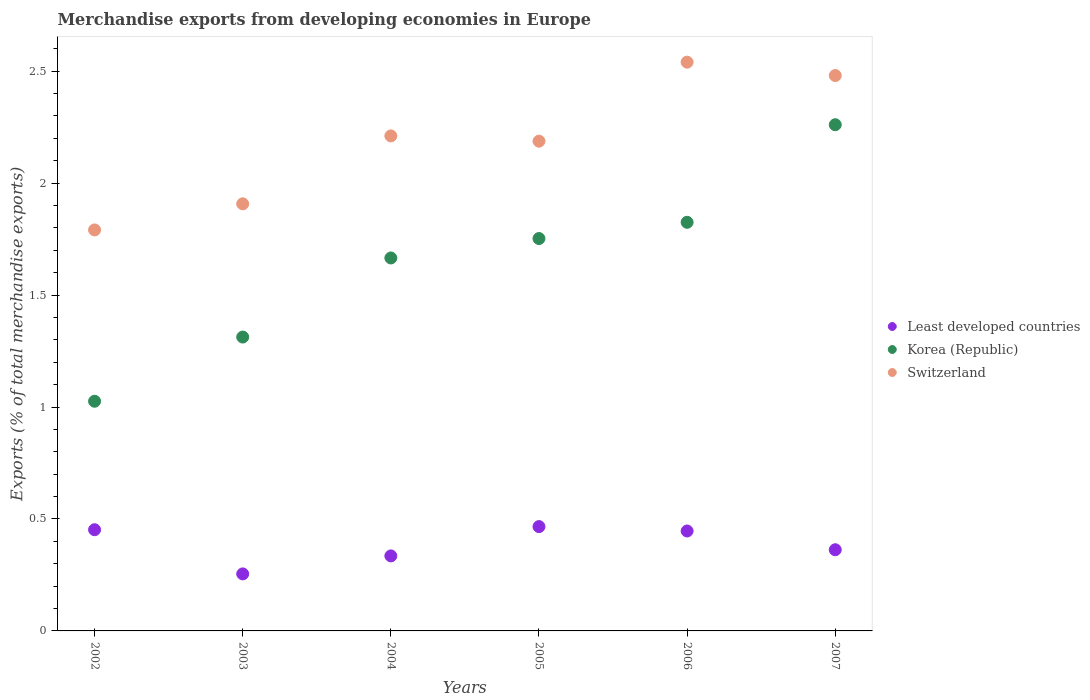How many different coloured dotlines are there?
Ensure brevity in your answer.  3. Is the number of dotlines equal to the number of legend labels?
Offer a terse response. Yes. What is the percentage of total merchandise exports in Switzerland in 2003?
Give a very brief answer. 1.91. Across all years, what is the maximum percentage of total merchandise exports in Least developed countries?
Make the answer very short. 0.47. Across all years, what is the minimum percentage of total merchandise exports in Switzerland?
Your answer should be compact. 1.79. In which year was the percentage of total merchandise exports in Least developed countries maximum?
Provide a short and direct response. 2005. What is the total percentage of total merchandise exports in Korea (Republic) in the graph?
Provide a succinct answer. 9.84. What is the difference between the percentage of total merchandise exports in Korea (Republic) in 2003 and that in 2005?
Give a very brief answer. -0.44. What is the difference between the percentage of total merchandise exports in Least developed countries in 2004 and the percentage of total merchandise exports in Korea (Republic) in 2002?
Provide a short and direct response. -0.69. What is the average percentage of total merchandise exports in Switzerland per year?
Give a very brief answer. 2.19. In the year 2002, what is the difference between the percentage of total merchandise exports in Switzerland and percentage of total merchandise exports in Korea (Republic)?
Your answer should be very brief. 0.77. In how many years, is the percentage of total merchandise exports in Least developed countries greater than 0.5 %?
Your answer should be compact. 0. What is the ratio of the percentage of total merchandise exports in Least developed countries in 2002 to that in 2003?
Keep it short and to the point. 1.77. Is the percentage of total merchandise exports in Switzerland in 2006 less than that in 2007?
Ensure brevity in your answer.  No. Is the difference between the percentage of total merchandise exports in Switzerland in 2003 and 2006 greater than the difference between the percentage of total merchandise exports in Korea (Republic) in 2003 and 2006?
Keep it short and to the point. No. What is the difference between the highest and the second highest percentage of total merchandise exports in Switzerland?
Give a very brief answer. 0.06. What is the difference between the highest and the lowest percentage of total merchandise exports in Switzerland?
Your response must be concise. 0.75. Is the sum of the percentage of total merchandise exports in Switzerland in 2004 and 2007 greater than the maximum percentage of total merchandise exports in Korea (Republic) across all years?
Offer a terse response. Yes. Does the percentage of total merchandise exports in Least developed countries monotonically increase over the years?
Ensure brevity in your answer.  No. Is the percentage of total merchandise exports in Switzerland strictly greater than the percentage of total merchandise exports in Korea (Republic) over the years?
Make the answer very short. Yes. How many years are there in the graph?
Provide a succinct answer. 6. Are the values on the major ticks of Y-axis written in scientific E-notation?
Make the answer very short. No. Does the graph contain any zero values?
Offer a very short reply. No. Does the graph contain grids?
Provide a succinct answer. No. What is the title of the graph?
Offer a terse response. Merchandise exports from developing economies in Europe. What is the label or title of the Y-axis?
Offer a terse response. Exports (% of total merchandise exports). What is the Exports (% of total merchandise exports) in Least developed countries in 2002?
Give a very brief answer. 0.45. What is the Exports (% of total merchandise exports) in Korea (Republic) in 2002?
Your answer should be very brief. 1.03. What is the Exports (% of total merchandise exports) of Switzerland in 2002?
Your answer should be compact. 1.79. What is the Exports (% of total merchandise exports) of Least developed countries in 2003?
Offer a terse response. 0.25. What is the Exports (% of total merchandise exports) of Korea (Republic) in 2003?
Provide a short and direct response. 1.31. What is the Exports (% of total merchandise exports) in Switzerland in 2003?
Make the answer very short. 1.91. What is the Exports (% of total merchandise exports) in Least developed countries in 2004?
Give a very brief answer. 0.34. What is the Exports (% of total merchandise exports) of Korea (Republic) in 2004?
Your response must be concise. 1.67. What is the Exports (% of total merchandise exports) in Switzerland in 2004?
Offer a very short reply. 2.21. What is the Exports (% of total merchandise exports) in Least developed countries in 2005?
Offer a very short reply. 0.47. What is the Exports (% of total merchandise exports) in Korea (Republic) in 2005?
Ensure brevity in your answer.  1.75. What is the Exports (% of total merchandise exports) in Switzerland in 2005?
Your answer should be very brief. 2.19. What is the Exports (% of total merchandise exports) of Least developed countries in 2006?
Your answer should be very brief. 0.45. What is the Exports (% of total merchandise exports) in Korea (Republic) in 2006?
Your response must be concise. 1.82. What is the Exports (% of total merchandise exports) in Switzerland in 2006?
Your response must be concise. 2.54. What is the Exports (% of total merchandise exports) in Least developed countries in 2007?
Give a very brief answer. 0.36. What is the Exports (% of total merchandise exports) of Korea (Republic) in 2007?
Keep it short and to the point. 2.26. What is the Exports (% of total merchandise exports) of Switzerland in 2007?
Provide a succinct answer. 2.48. Across all years, what is the maximum Exports (% of total merchandise exports) of Least developed countries?
Provide a short and direct response. 0.47. Across all years, what is the maximum Exports (% of total merchandise exports) in Korea (Republic)?
Make the answer very short. 2.26. Across all years, what is the maximum Exports (% of total merchandise exports) in Switzerland?
Offer a terse response. 2.54. Across all years, what is the minimum Exports (% of total merchandise exports) of Least developed countries?
Provide a short and direct response. 0.25. Across all years, what is the minimum Exports (% of total merchandise exports) in Korea (Republic)?
Give a very brief answer. 1.03. Across all years, what is the minimum Exports (% of total merchandise exports) in Switzerland?
Keep it short and to the point. 1.79. What is the total Exports (% of total merchandise exports) of Least developed countries in the graph?
Provide a succinct answer. 2.32. What is the total Exports (% of total merchandise exports) in Korea (Republic) in the graph?
Your answer should be compact. 9.84. What is the total Exports (% of total merchandise exports) of Switzerland in the graph?
Provide a succinct answer. 13.12. What is the difference between the Exports (% of total merchandise exports) of Least developed countries in 2002 and that in 2003?
Your answer should be very brief. 0.2. What is the difference between the Exports (% of total merchandise exports) in Korea (Republic) in 2002 and that in 2003?
Your response must be concise. -0.29. What is the difference between the Exports (% of total merchandise exports) in Switzerland in 2002 and that in 2003?
Ensure brevity in your answer.  -0.12. What is the difference between the Exports (% of total merchandise exports) of Least developed countries in 2002 and that in 2004?
Keep it short and to the point. 0.12. What is the difference between the Exports (% of total merchandise exports) of Korea (Republic) in 2002 and that in 2004?
Provide a succinct answer. -0.64. What is the difference between the Exports (% of total merchandise exports) in Switzerland in 2002 and that in 2004?
Keep it short and to the point. -0.42. What is the difference between the Exports (% of total merchandise exports) of Least developed countries in 2002 and that in 2005?
Ensure brevity in your answer.  -0.01. What is the difference between the Exports (% of total merchandise exports) of Korea (Republic) in 2002 and that in 2005?
Your response must be concise. -0.73. What is the difference between the Exports (% of total merchandise exports) in Switzerland in 2002 and that in 2005?
Provide a succinct answer. -0.4. What is the difference between the Exports (% of total merchandise exports) of Least developed countries in 2002 and that in 2006?
Provide a succinct answer. 0.01. What is the difference between the Exports (% of total merchandise exports) in Korea (Republic) in 2002 and that in 2006?
Your response must be concise. -0.8. What is the difference between the Exports (% of total merchandise exports) in Switzerland in 2002 and that in 2006?
Make the answer very short. -0.75. What is the difference between the Exports (% of total merchandise exports) in Least developed countries in 2002 and that in 2007?
Keep it short and to the point. 0.09. What is the difference between the Exports (% of total merchandise exports) of Korea (Republic) in 2002 and that in 2007?
Your answer should be very brief. -1.24. What is the difference between the Exports (% of total merchandise exports) in Switzerland in 2002 and that in 2007?
Provide a succinct answer. -0.69. What is the difference between the Exports (% of total merchandise exports) of Least developed countries in 2003 and that in 2004?
Provide a succinct answer. -0.08. What is the difference between the Exports (% of total merchandise exports) of Korea (Republic) in 2003 and that in 2004?
Keep it short and to the point. -0.35. What is the difference between the Exports (% of total merchandise exports) of Switzerland in 2003 and that in 2004?
Ensure brevity in your answer.  -0.3. What is the difference between the Exports (% of total merchandise exports) of Least developed countries in 2003 and that in 2005?
Keep it short and to the point. -0.21. What is the difference between the Exports (% of total merchandise exports) in Korea (Republic) in 2003 and that in 2005?
Your answer should be compact. -0.44. What is the difference between the Exports (% of total merchandise exports) of Switzerland in 2003 and that in 2005?
Your answer should be compact. -0.28. What is the difference between the Exports (% of total merchandise exports) in Least developed countries in 2003 and that in 2006?
Keep it short and to the point. -0.19. What is the difference between the Exports (% of total merchandise exports) of Korea (Republic) in 2003 and that in 2006?
Provide a short and direct response. -0.51. What is the difference between the Exports (% of total merchandise exports) in Switzerland in 2003 and that in 2006?
Ensure brevity in your answer.  -0.63. What is the difference between the Exports (% of total merchandise exports) of Least developed countries in 2003 and that in 2007?
Offer a terse response. -0.11. What is the difference between the Exports (% of total merchandise exports) in Korea (Republic) in 2003 and that in 2007?
Your response must be concise. -0.95. What is the difference between the Exports (% of total merchandise exports) of Switzerland in 2003 and that in 2007?
Ensure brevity in your answer.  -0.57. What is the difference between the Exports (% of total merchandise exports) in Least developed countries in 2004 and that in 2005?
Provide a short and direct response. -0.13. What is the difference between the Exports (% of total merchandise exports) of Korea (Republic) in 2004 and that in 2005?
Your answer should be compact. -0.09. What is the difference between the Exports (% of total merchandise exports) in Switzerland in 2004 and that in 2005?
Make the answer very short. 0.02. What is the difference between the Exports (% of total merchandise exports) of Least developed countries in 2004 and that in 2006?
Provide a short and direct response. -0.11. What is the difference between the Exports (% of total merchandise exports) in Korea (Republic) in 2004 and that in 2006?
Ensure brevity in your answer.  -0.16. What is the difference between the Exports (% of total merchandise exports) of Switzerland in 2004 and that in 2006?
Offer a very short reply. -0.33. What is the difference between the Exports (% of total merchandise exports) in Least developed countries in 2004 and that in 2007?
Offer a terse response. -0.03. What is the difference between the Exports (% of total merchandise exports) in Korea (Republic) in 2004 and that in 2007?
Your answer should be very brief. -0.6. What is the difference between the Exports (% of total merchandise exports) in Switzerland in 2004 and that in 2007?
Your answer should be compact. -0.27. What is the difference between the Exports (% of total merchandise exports) of Least developed countries in 2005 and that in 2006?
Keep it short and to the point. 0.02. What is the difference between the Exports (% of total merchandise exports) in Korea (Republic) in 2005 and that in 2006?
Offer a very short reply. -0.07. What is the difference between the Exports (% of total merchandise exports) of Switzerland in 2005 and that in 2006?
Offer a terse response. -0.35. What is the difference between the Exports (% of total merchandise exports) of Least developed countries in 2005 and that in 2007?
Give a very brief answer. 0.1. What is the difference between the Exports (% of total merchandise exports) in Korea (Republic) in 2005 and that in 2007?
Make the answer very short. -0.51. What is the difference between the Exports (% of total merchandise exports) in Switzerland in 2005 and that in 2007?
Make the answer very short. -0.29. What is the difference between the Exports (% of total merchandise exports) in Least developed countries in 2006 and that in 2007?
Ensure brevity in your answer.  0.08. What is the difference between the Exports (% of total merchandise exports) of Korea (Republic) in 2006 and that in 2007?
Provide a succinct answer. -0.44. What is the difference between the Exports (% of total merchandise exports) of Switzerland in 2006 and that in 2007?
Your response must be concise. 0.06. What is the difference between the Exports (% of total merchandise exports) of Least developed countries in 2002 and the Exports (% of total merchandise exports) of Korea (Republic) in 2003?
Provide a succinct answer. -0.86. What is the difference between the Exports (% of total merchandise exports) in Least developed countries in 2002 and the Exports (% of total merchandise exports) in Switzerland in 2003?
Provide a short and direct response. -1.46. What is the difference between the Exports (% of total merchandise exports) of Korea (Republic) in 2002 and the Exports (% of total merchandise exports) of Switzerland in 2003?
Make the answer very short. -0.88. What is the difference between the Exports (% of total merchandise exports) of Least developed countries in 2002 and the Exports (% of total merchandise exports) of Korea (Republic) in 2004?
Your answer should be very brief. -1.21. What is the difference between the Exports (% of total merchandise exports) of Least developed countries in 2002 and the Exports (% of total merchandise exports) of Switzerland in 2004?
Your response must be concise. -1.76. What is the difference between the Exports (% of total merchandise exports) in Korea (Republic) in 2002 and the Exports (% of total merchandise exports) in Switzerland in 2004?
Your response must be concise. -1.19. What is the difference between the Exports (% of total merchandise exports) in Least developed countries in 2002 and the Exports (% of total merchandise exports) in Korea (Republic) in 2005?
Your response must be concise. -1.3. What is the difference between the Exports (% of total merchandise exports) in Least developed countries in 2002 and the Exports (% of total merchandise exports) in Switzerland in 2005?
Give a very brief answer. -1.74. What is the difference between the Exports (% of total merchandise exports) in Korea (Republic) in 2002 and the Exports (% of total merchandise exports) in Switzerland in 2005?
Ensure brevity in your answer.  -1.16. What is the difference between the Exports (% of total merchandise exports) in Least developed countries in 2002 and the Exports (% of total merchandise exports) in Korea (Republic) in 2006?
Offer a terse response. -1.37. What is the difference between the Exports (% of total merchandise exports) in Least developed countries in 2002 and the Exports (% of total merchandise exports) in Switzerland in 2006?
Provide a short and direct response. -2.09. What is the difference between the Exports (% of total merchandise exports) of Korea (Republic) in 2002 and the Exports (% of total merchandise exports) of Switzerland in 2006?
Your answer should be very brief. -1.51. What is the difference between the Exports (% of total merchandise exports) of Least developed countries in 2002 and the Exports (% of total merchandise exports) of Korea (Republic) in 2007?
Keep it short and to the point. -1.81. What is the difference between the Exports (% of total merchandise exports) of Least developed countries in 2002 and the Exports (% of total merchandise exports) of Switzerland in 2007?
Offer a terse response. -2.03. What is the difference between the Exports (% of total merchandise exports) in Korea (Republic) in 2002 and the Exports (% of total merchandise exports) in Switzerland in 2007?
Ensure brevity in your answer.  -1.45. What is the difference between the Exports (% of total merchandise exports) of Least developed countries in 2003 and the Exports (% of total merchandise exports) of Korea (Republic) in 2004?
Your response must be concise. -1.41. What is the difference between the Exports (% of total merchandise exports) of Least developed countries in 2003 and the Exports (% of total merchandise exports) of Switzerland in 2004?
Your response must be concise. -1.96. What is the difference between the Exports (% of total merchandise exports) in Korea (Republic) in 2003 and the Exports (% of total merchandise exports) in Switzerland in 2004?
Keep it short and to the point. -0.9. What is the difference between the Exports (% of total merchandise exports) of Least developed countries in 2003 and the Exports (% of total merchandise exports) of Korea (Republic) in 2005?
Your answer should be very brief. -1.5. What is the difference between the Exports (% of total merchandise exports) of Least developed countries in 2003 and the Exports (% of total merchandise exports) of Switzerland in 2005?
Provide a short and direct response. -1.93. What is the difference between the Exports (% of total merchandise exports) in Korea (Republic) in 2003 and the Exports (% of total merchandise exports) in Switzerland in 2005?
Your answer should be compact. -0.87. What is the difference between the Exports (% of total merchandise exports) in Least developed countries in 2003 and the Exports (% of total merchandise exports) in Korea (Republic) in 2006?
Your response must be concise. -1.57. What is the difference between the Exports (% of total merchandise exports) in Least developed countries in 2003 and the Exports (% of total merchandise exports) in Switzerland in 2006?
Provide a succinct answer. -2.29. What is the difference between the Exports (% of total merchandise exports) in Korea (Republic) in 2003 and the Exports (% of total merchandise exports) in Switzerland in 2006?
Provide a short and direct response. -1.23. What is the difference between the Exports (% of total merchandise exports) of Least developed countries in 2003 and the Exports (% of total merchandise exports) of Korea (Republic) in 2007?
Offer a terse response. -2.01. What is the difference between the Exports (% of total merchandise exports) in Least developed countries in 2003 and the Exports (% of total merchandise exports) in Switzerland in 2007?
Your answer should be compact. -2.23. What is the difference between the Exports (% of total merchandise exports) in Korea (Republic) in 2003 and the Exports (% of total merchandise exports) in Switzerland in 2007?
Offer a terse response. -1.17. What is the difference between the Exports (% of total merchandise exports) in Least developed countries in 2004 and the Exports (% of total merchandise exports) in Korea (Republic) in 2005?
Offer a very short reply. -1.42. What is the difference between the Exports (% of total merchandise exports) of Least developed countries in 2004 and the Exports (% of total merchandise exports) of Switzerland in 2005?
Offer a very short reply. -1.85. What is the difference between the Exports (% of total merchandise exports) of Korea (Republic) in 2004 and the Exports (% of total merchandise exports) of Switzerland in 2005?
Provide a short and direct response. -0.52. What is the difference between the Exports (% of total merchandise exports) in Least developed countries in 2004 and the Exports (% of total merchandise exports) in Korea (Republic) in 2006?
Keep it short and to the point. -1.49. What is the difference between the Exports (% of total merchandise exports) in Least developed countries in 2004 and the Exports (% of total merchandise exports) in Switzerland in 2006?
Your answer should be compact. -2.21. What is the difference between the Exports (% of total merchandise exports) of Korea (Republic) in 2004 and the Exports (% of total merchandise exports) of Switzerland in 2006?
Your response must be concise. -0.87. What is the difference between the Exports (% of total merchandise exports) of Least developed countries in 2004 and the Exports (% of total merchandise exports) of Korea (Republic) in 2007?
Keep it short and to the point. -1.93. What is the difference between the Exports (% of total merchandise exports) in Least developed countries in 2004 and the Exports (% of total merchandise exports) in Switzerland in 2007?
Offer a terse response. -2.15. What is the difference between the Exports (% of total merchandise exports) of Korea (Republic) in 2004 and the Exports (% of total merchandise exports) of Switzerland in 2007?
Give a very brief answer. -0.81. What is the difference between the Exports (% of total merchandise exports) in Least developed countries in 2005 and the Exports (% of total merchandise exports) in Korea (Republic) in 2006?
Provide a short and direct response. -1.36. What is the difference between the Exports (% of total merchandise exports) of Least developed countries in 2005 and the Exports (% of total merchandise exports) of Switzerland in 2006?
Ensure brevity in your answer.  -2.07. What is the difference between the Exports (% of total merchandise exports) of Korea (Republic) in 2005 and the Exports (% of total merchandise exports) of Switzerland in 2006?
Provide a succinct answer. -0.79. What is the difference between the Exports (% of total merchandise exports) in Least developed countries in 2005 and the Exports (% of total merchandise exports) in Korea (Republic) in 2007?
Provide a short and direct response. -1.79. What is the difference between the Exports (% of total merchandise exports) in Least developed countries in 2005 and the Exports (% of total merchandise exports) in Switzerland in 2007?
Your response must be concise. -2.01. What is the difference between the Exports (% of total merchandise exports) of Korea (Republic) in 2005 and the Exports (% of total merchandise exports) of Switzerland in 2007?
Provide a short and direct response. -0.73. What is the difference between the Exports (% of total merchandise exports) in Least developed countries in 2006 and the Exports (% of total merchandise exports) in Korea (Republic) in 2007?
Offer a terse response. -1.81. What is the difference between the Exports (% of total merchandise exports) in Least developed countries in 2006 and the Exports (% of total merchandise exports) in Switzerland in 2007?
Provide a short and direct response. -2.03. What is the difference between the Exports (% of total merchandise exports) of Korea (Republic) in 2006 and the Exports (% of total merchandise exports) of Switzerland in 2007?
Ensure brevity in your answer.  -0.66. What is the average Exports (% of total merchandise exports) of Least developed countries per year?
Offer a very short reply. 0.39. What is the average Exports (% of total merchandise exports) of Korea (Republic) per year?
Provide a short and direct response. 1.64. What is the average Exports (% of total merchandise exports) of Switzerland per year?
Keep it short and to the point. 2.19. In the year 2002, what is the difference between the Exports (% of total merchandise exports) in Least developed countries and Exports (% of total merchandise exports) in Korea (Republic)?
Give a very brief answer. -0.57. In the year 2002, what is the difference between the Exports (% of total merchandise exports) of Least developed countries and Exports (% of total merchandise exports) of Switzerland?
Your answer should be very brief. -1.34. In the year 2002, what is the difference between the Exports (% of total merchandise exports) of Korea (Republic) and Exports (% of total merchandise exports) of Switzerland?
Offer a very short reply. -0.77. In the year 2003, what is the difference between the Exports (% of total merchandise exports) in Least developed countries and Exports (% of total merchandise exports) in Korea (Republic)?
Give a very brief answer. -1.06. In the year 2003, what is the difference between the Exports (% of total merchandise exports) of Least developed countries and Exports (% of total merchandise exports) of Switzerland?
Offer a very short reply. -1.65. In the year 2003, what is the difference between the Exports (% of total merchandise exports) in Korea (Republic) and Exports (% of total merchandise exports) in Switzerland?
Your answer should be compact. -0.59. In the year 2004, what is the difference between the Exports (% of total merchandise exports) of Least developed countries and Exports (% of total merchandise exports) of Korea (Republic)?
Your answer should be compact. -1.33. In the year 2004, what is the difference between the Exports (% of total merchandise exports) of Least developed countries and Exports (% of total merchandise exports) of Switzerland?
Offer a very short reply. -1.88. In the year 2004, what is the difference between the Exports (% of total merchandise exports) of Korea (Republic) and Exports (% of total merchandise exports) of Switzerland?
Make the answer very short. -0.55. In the year 2005, what is the difference between the Exports (% of total merchandise exports) of Least developed countries and Exports (% of total merchandise exports) of Korea (Republic)?
Make the answer very short. -1.29. In the year 2005, what is the difference between the Exports (% of total merchandise exports) in Least developed countries and Exports (% of total merchandise exports) in Switzerland?
Provide a short and direct response. -1.72. In the year 2005, what is the difference between the Exports (% of total merchandise exports) in Korea (Republic) and Exports (% of total merchandise exports) in Switzerland?
Your answer should be compact. -0.43. In the year 2006, what is the difference between the Exports (% of total merchandise exports) in Least developed countries and Exports (% of total merchandise exports) in Korea (Republic)?
Offer a terse response. -1.38. In the year 2006, what is the difference between the Exports (% of total merchandise exports) in Least developed countries and Exports (% of total merchandise exports) in Switzerland?
Offer a very short reply. -2.09. In the year 2006, what is the difference between the Exports (% of total merchandise exports) in Korea (Republic) and Exports (% of total merchandise exports) in Switzerland?
Your answer should be compact. -0.72. In the year 2007, what is the difference between the Exports (% of total merchandise exports) in Least developed countries and Exports (% of total merchandise exports) in Korea (Republic)?
Your answer should be compact. -1.9. In the year 2007, what is the difference between the Exports (% of total merchandise exports) in Least developed countries and Exports (% of total merchandise exports) in Switzerland?
Make the answer very short. -2.12. In the year 2007, what is the difference between the Exports (% of total merchandise exports) in Korea (Republic) and Exports (% of total merchandise exports) in Switzerland?
Ensure brevity in your answer.  -0.22. What is the ratio of the Exports (% of total merchandise exports) in Least developed countries in 2002 to that in 2003?
Ensure brevity in your answer.  1.77. What is the ratio of the Exports (% of total merchandise exports) in Korea (Republic) in 2002 to that in 2003?
Provide a succinct answer. 0.78. What is the ratio of the Exports (% of total merchandise exports) of Switzerland in 2002 to that in 2003?
Your answer should be very brief. 0.94. What is the ratio of the Exports (% of total merchandise exports) in Least developed countries in 2002 to that in 2004?
Provide a short and direct response. 1.35. What is the ratio of the Exports (% of total merchandise exports) of Korea (Republic) in 2002 to that in 2004?
Keep it short and to the point. 0.62. What is the ratio of the Exports (% of total merchandise exports) of Switzerland in 2002 to that in 2004?
Give a very brief answer. 0.81. What is the ratio of the Exports (% of total merchandise exports) in Least developed countries in 2002 to that in 2005?
Keep it short and to the point. 0.97. What is the ratio of the Exports (% of total merchandise exports) in Korea (Republic) in 2002 to that in 2005?
Your response must be concise. 0.59. What is the ratio of the Exports (% of total merchandise exports) of Switzerland in 2002 to that in 2005?
Give a very brief answer. 0.82. What is the ratio of the Exports (% of total merchandise exports) of Least developed countries in 2002 to that in 2006?
Make the answer very short. 1.01. What is the ratio of the Exports (% of total merchandise exports) of Korea (Republic) in 2002 to that in 2006?
Provide a short and direct response. 0.56. What is the ratio of the Exports (% of total merchandise exports) of Switzerland in 2002 to that in 2006?
Ensure brevity in your answer.  0.7. What is the ratio of the Exports (% of total merchandise exports) in Least developed countries in 2002 to that in 2007?
Provide a succinct answer. 1.25. What is the ratio of the Exports (% of total merchandise exports) in Korea (Republic) in 2002 to that in 2007?
Your answer should be very brief. 0.45. What is the ratio of the Exports (% of total merchandise exports) of Switzerland in 2002 to that in 2007?
Your response must be concise. 0.72. What is the ratio of the Exports (% of total merchandise exports) in Least developed countries in 2003 to that in 2004?
Keep it short and to the point. 0.76. What is the ratio of the Exports (% of total merchandise exports) of Korea (Republic) in 2003 to that in 2004?
Give a very brief answer. 0.79. What is the ratio of the Exports (% of total merchandise exports) in Switzerland in 2003 to that in 2004?
Provide a short and direct response. 0.86. What is the ratio of the Exports (% of total merchandise exports) in Least developed countries in 2003 to that in 2005?
Ensure brevity in your answer.  0.55. What is the ratio of the Exports (% of total merchandise exports) in Korea (Republic) in 2003 to that in 2005?
Provide a succinct answer. 0.75. What is the ratio of the Exports (% of total merchandise exports) of Switzerland in 2003 to that in 2005?
Provide a succinct answer. 0.87. What is the ratio of the Exports (% of total merchandise exports) in Least developed countries in 2003 to that in 2006?
Your answer should be very brief. 0.57. What is the ratio of the Exports (% of total merchandise exports) in Korea (Republic) in 2003 to that in 2006?
Make the answer very short. 0.72. What is the ratio of the Exports (% of total merchandise exports) in Switzerland in 2003 to that in 2006?
Ensure brevity in your answer.  0.75. What is the ratio of the Exports (% of total merchandise exports) in Least developed countries in 2003 to that in 2007?
Ensure brevity in your answer.  0.7. What is the ratio of the Exports (% of total merchandise exports) in Korea (Republic) in 2003 to that in 2007?
Offer a very short reply. 0.58. What is the ratio of the Exports (% of total merchandise exports) of Switzerland in 2003 to that in 2007?
Provide a short and direct response. 0.77. What is the ratio of the Exports (% of total merchandise exports) in Least developed countries in 2004 to that in 2005?
Offer a very short reply. 0.72. What is the ratio of the Exports (% of total merchandise exports) in Korea (Republic) in 2004 to that in 2005?
Give a very brief answer. 0.95. What is the ratio of the Exports (% of total merchandise exports) in Switzerland in 2004 to that in 2005?
Provide a succinct answer. 1.01. What is the ratio of the Exports (% of total merchandise exports) of Least developed countries in 2004 to that in 2006?
Provide a succinct answer. 0.75. What is the ratio of the Exports (% of total merchandise exports) in Korea (Republic) in 2004 to that in 2006?
Your response must be concise. 0.91. What is the ratio of the Exports (% of total merchandise exports) in Switzerland in 2004 to that in 2006?
Your answer should be compact. 0.87. What is the ratio of the Exports (% of total merchandise exports) in Least developed countries in 2004 to that in 2007?
Offer a terse response. 0.92. What is the ratio of the Exports (% of total merchandise exports) of Korea (Republic) in 2004 to that in 2007?
Give a very brief answer. 0.74. What is the ratio of the Exports (% of total merchandise exports) in Switzerland in 2004 to that in 2007?
Provide a short and direct response. 0.89. What is the ratio of the Exports (% of total merchandise exports) of Least developed countries in 2005 to that in 2006?
Offer a very short reply. 1.04. What is the ratio of the Exports (% of total merchandise exports) of Korea (Republic) in 2005 to that in 2006?
Ensure brevity in your answer.  0.96. What is the ratio of the Exports (% of total merchandise exports) in Switzerland in 2005 to that in 2006?
Provide a succinct answer. 0.86. What is the ratio of the Exports (% of total merchandise exports) of Least developed countries in 2005 to that in 2007?
Provide a succinct answer. 1.29. What is the ratio of the Exports (% of total merchandise exports) of Korea (Republic) in 2005 to that in 2007?
Provide a succinct answer. 0.78. What is the ratio of the Exports (% of total merchandise exports) of Switzerland in 2005 to that in 2007?
Provide a short and direct response. 0.88. What is the ratio of the Exports (% of total merchandise exports) in Least developed countries in 2006 to that in 2007?
Your response must be concise. 1.23. What is the ratio of the Exports (% of total merchandise exports) of Korea (Republic) in 2006 to that in 2007?
Your answer should be compact. 0.81. What is the ratio of the Exports (% of total merchandise exports) of Switzerland in 2006 to that in 2007?
Ensure brevity in your answer.  1.02. What is the difference between the highest and the second highest Exports (% of total merchandise exports) in Least developed countries?
Ensure brevity in your answer.  0.01. What is the difference between the highest and the second highest Exports (% of total merchandise exports) of Korea (Republic)?
Make the answer very short. 0.44. What is the difference between the highest and the second highest Exports (% of total merchandise exports) in Switzerland?
Make the answer very short. 0.06. What is the difference between the highest and the lowest Exports (% of total merchandise exports) of Least developed countries?
Make the answer very short. 0.21. What is the difference between the highest and the lowest Exports (% of total merchandise exports) in Korea (Republic)?
Offer a terse response. 1.24. What is the difference between the highest and the lowest Exports (% of total merchandise exports) of Switzerland?
Give a very brief answer. 0.75. 